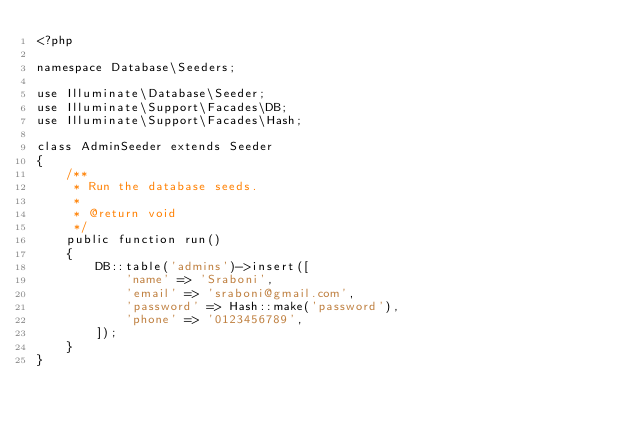<code> <loc_0><loc_0><loc_500><loc_500><_PHP_><?php

namespace Database\Seeders;

use Illuminate\Database\Seeder;
use Illuminate\Support\Facades\DB;
use Illuminate\Support\Facades\Hash;

class AdminSeeder extends Seeder
{
    /**
     * Run the database seeds.
     *
     * @return void
     */
    public function run()
    {
        DB::table('admins')->insert([
            'name' => 'Sraboni',
            'email' => 'sraboni@gmail.com',
            'password' => Hash::make('password'),
            'phone' => '0123456789',
        ]);
    }
}
</code> 